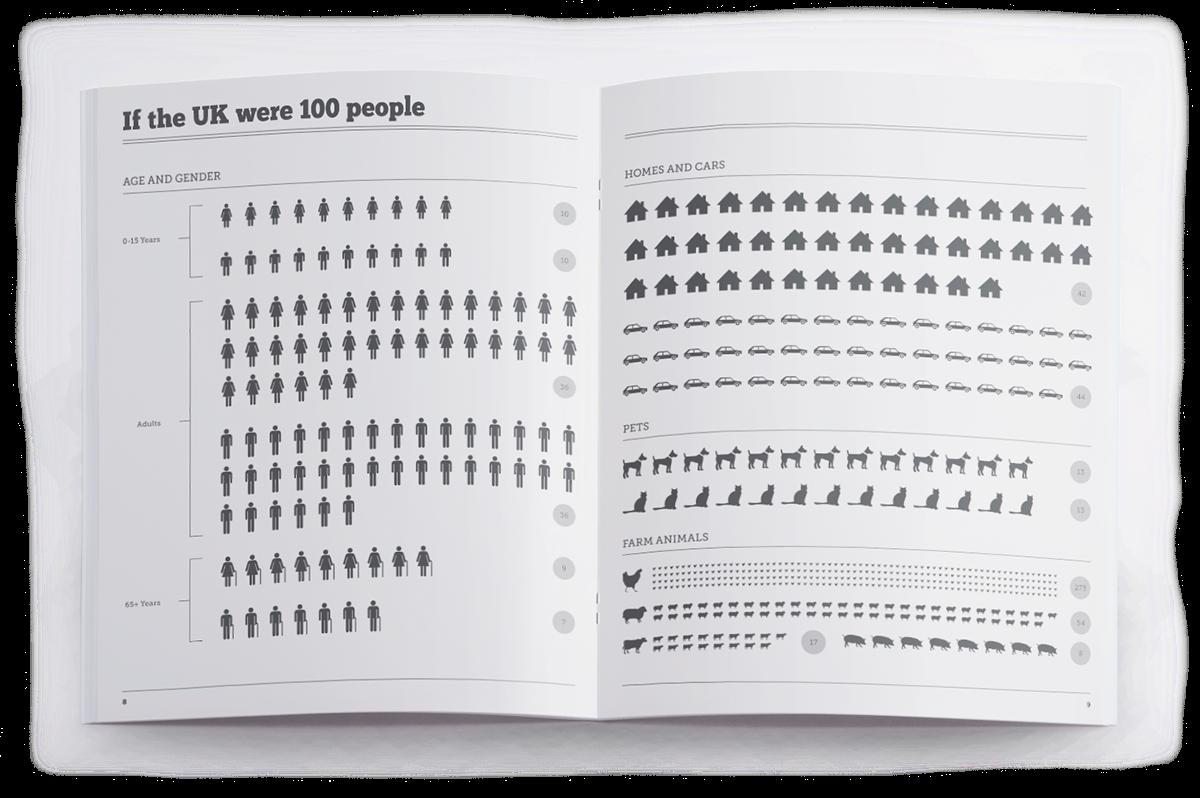Outline some significant characteristics in this image. There are approximately 16 million senior citizens living in the United Kingdom. There are 36 adult men and 36 adult women among a total of 72 adults. There are 10 girls and 10 boys in a group of 20 children aged 0-15. There are a total of 25 farm animals, which include cows and pigs. The total number of pets is 26. 